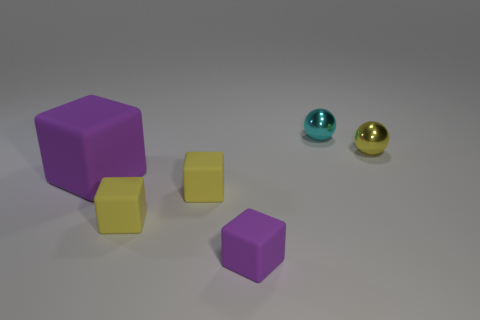How many other objects have the same color as the big thing?
Offer a very short reply. 1. There is a metal sphere on the right side of the small cyan sphere; is it the same color as the large rubber object?
Ensure brevity in your answer.  No. What number of other objects are the same size as the cyan sphere?
Provide a succinct answer. 4. Are the tiny yellow sphere and the tiny purple thing made of the same material?
Provide a short and direct response. No. There is a metal thing behind the small metal object that is in front of the cyan sphere; what color is it?
Provide a succinct answer. Cyan. There is another purple object that is the same shape as the small purple rubber object; what size is it?
Give a very brief answer. Large. There is a tiny yellow object that is behind the purple matte block on the left side of the tiny purple matte block; how many small shiny spheres are to the right of it?
Ensure brevity in your answer.  0. Is the number of small blue rubber balls greater than the number of small yellow cubes?
Your answer should be very brief. No. What number of small yellow spheres are there?
Make the answer very short. 1. There is a small purple rubber thing that is in front of the metal object left of the yellow thing that is behind the big purple block; what shape is it?
Keep it short and to the point. Cube. 